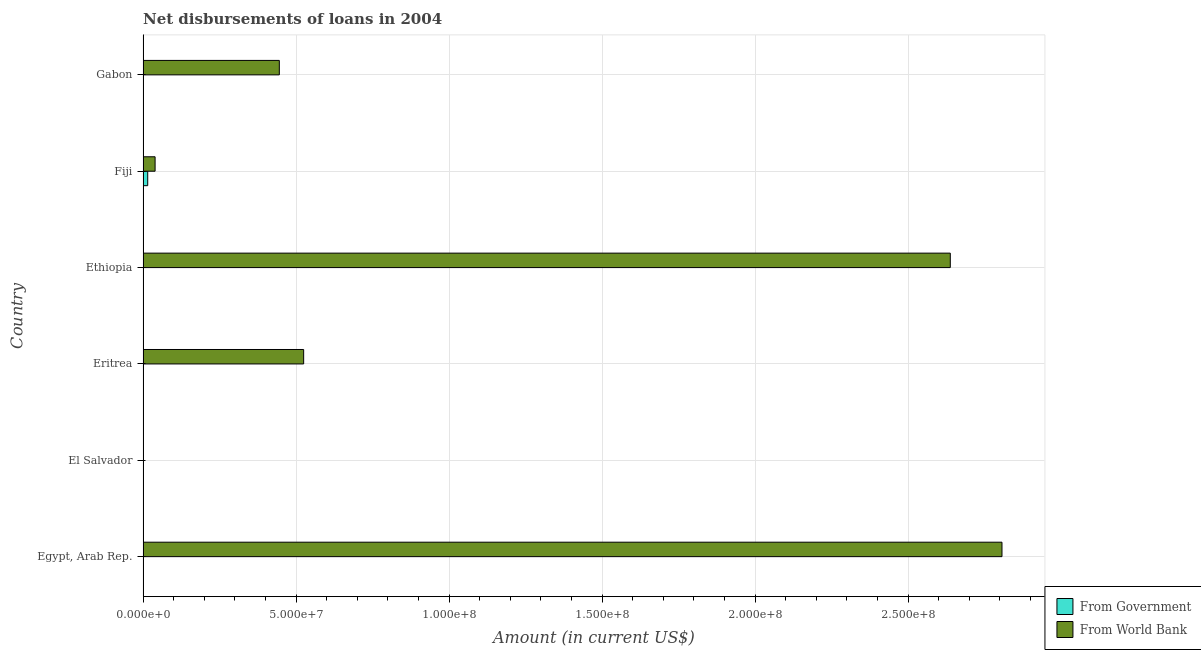Are the number of bars on each tick of the Y-axis equal?
Offer a very short reply. No. How many bars are there on the 3rd tick from the top?
Provide a succinct answer. 1. How many bars are there on the 1st tick from the bottom?
Keep it short and to the point. 1. What is the label of the 5th group of bars from the top?
Ensure brevity in your answer.  El Salvador. In how many cases, is the number of bars for a given country not equal to the number of legend labels?
Offer a terse response. 5. Across all countries, what is the maximum net disbursements of loan from government?
Your answer should be compact. 1.52e+06. Across all countries, what is the minimum net disbursements of loan from government?
Give a very brief answer. 0. In which country was the net disbursements of loan from government maximum?
Your answer should be very brief. Fiji. What is the total net disbursements of loan from government in the graph?
Make the answer very short. 1.52e+06. What is the difference between the net disbursements of loan from world bank in Ethiopia and that in Gabon?
Your answer should be compact. 2.19e+08. What is the difference between the net disbursements of loan from government in Fiji and the net disbursements of loan from world bank in Egypt, Arab Rep.?
Provide a succinct answer. -2.79e+08. What is the average net disbursements of loan from government per country?
Offer a very short reply. 2.54e+05. What is the difference between the net disbursements of loan from government and net disbursements of loan from world bank in Fiji?
Ensure brevity in your answer.  -2.41e+06. In how many countries, is the net disbursements of loan from world bank greater than 230000000 US$?
Your answer should be very brief. 2. What is the ratio of the net disbursements of loan from world bank in Eritrea to that in Ethiopia?
Your response must be concise. 0.2. What is the difference between the highest and the second highest net disbursements of loan from world bank?
Keep it short and to the point. 1.69e+07. What is the difference between the highest and the lowest net disbursements of loan from government?
Make the answer very short. 1.52e+06. In how many countries, is the net disbursements of loan from world bank greater than the average net disbursements of loan from world bank taken over all countries?
Your answer should be very brief. 2. Is the sum of the net disbursements of loan from world bank in Eritrea and Fiji greater than the maximum net disbursements of loan from government across all countries?
Provide a short and direct response. Yes. How many bars are there?
Offer a terse response. 6. How many countries are there in the graph?
Ensure brevity in your answer.  6. What is the difference between two consecutive major ticks on the X-axis?
Your response must be concise. 5.00e+07. Are the values on the major ticks of X-axis written in scientific E-notation?
Provide a succinct answer. Yes. Does the graph contain any zero values?
Offer a very short reply. Yes. How many legend labels are there?
Your answer should be very brief. 2. How are the legend labels stacked?
Ensure brevity in your answer.  Vertical. What is the title of the graph?
Keep it short and to the point. Net disbursements of loans in 2004. What is the label or title of the X-axis?
Offer a terse response. Amount (in current US$). What is the Amount (in current US$) in From World Bank in Egypt, Arab Rep.?
Your answer should be very brief. 2.81e+08. What is the Amount (in current US$) in From Government in El Salvador?
Your answer should be very brief. 0. What is the Amount (in current US$) of From World Bank in El Salvador?
Your answer should be very brief. 0. What is the Amount (in current US$) of From Government in Eritrea?
Provide a short and direct response. 0. What is the Amount (in current US$) of From World Bank in Eritrea?
Ensure brevity in your answer.  5.25e+07. What is the Amount (in current US$) of From World Bank in Ethiopia?
Ensure brevity in your answer.  2.64e+08. What is the Amount (in current US$) in From Government in Fiji?
Provide a short and direct response. 1.52e+06. What is the Amount (in current US$) in From World Bank in Fiji?
Provide a short and direct response. 3.93e+06. What is the Amount (in current US$) in From World Bank in Gabon?
Provide a short and direct response. 4.45e+07. Across all countries, what is the maximum Amount (in current US$) in From Government?
Make the answer very short. 1.52e+06. Across all countries, what is the maximum Amount (in current US$) in From World Bank?
Your response must be concise. 2.81e+08. Across all countries, what is the minimum Amount (in current US$) in From Government?
Give a very brief answer. 0. Across all countries, what is the minimum Amount (in current US$) of From World Bank?
Make the answer very short. 0. What is the total Amount (in current US$) of From Government in the graph?
Give a very brief answer. 1.52e+06. What is the total Amount (in current US$) in From World Bank in the graph?
Ensure brevity in your answer.  6.45e+08. What is the difference between the Amount (in current US$) in From World Bank in Egypt, Arab Rep. and that in Eritrea?
Make the answer very short. 2.28e+08. What is the difference between the Amount (in current US$) in From World Bank in Egypt, Arab Rep. and that in Ethiopia?
Your answer should be very brief. 1.69e+07. What is the difference between the Amount (in current US$) in From World Bank in Egypt, Arab Rep. and that in Fiji?
Your answer should be compact. 2.77e+08. What is the difference between the Amount (in current US$) of From World Bank in Egypt, Arab Rep. and that in Gabon?
Offer a terse response. 2.36e+08. What is the difference between the Amount (in current US$) in From World Bank in Eritrea and that in Ethiopia?
Make the answer very short. -2.11e+08. What is the difference between the Amount (in current US$) of From World Bank in Eritrea and that in Fiji?
Provide a succinct answer. 4.86e+07. What is the difference between the Amount (in current US$) of From World Bank in Eritrea and that in Gabon?
Your answer should be very brief. 7.95e+06. What is the difference between the Amount (in current US$) of From World Bank in Ethiopia and that in Fiji?
Give a very brief answer. 2.60e+08. What is the difference between the Amount (in current US$) in From World Bank in Ethiopia and that in Gabon?
Ensure brevity in your answer.  2.19e+08. What is the difference between the Amount (in current US$) of From World Bank in Fiji and that in Gabon?
Keep it short and to the point. -4.06e+07. What is the difference between the Amount (in current US$) in From Government in Fiji and the Amount (in current US$) in From World Bank in Gabon?
Provide a short and direct response. -4.30e+07. What is the average Amount (in current US$) of From Government per country?
Ensure brevity in your answer.  2.54e+05. What is the average Amount (in current US$) in From World Bank per country?
Your answer should be very brief. 1.08e+08. What is the difference between the Amount (in current US$) in From Government and Amount (in current US$) in From World Bank in Fiji?
Your answer should be very brief. -2.41e+06. What is the ratio of the Amount (in current US$) in From World Bank in Egypt, Arab Rep. to that in Eritrea?
Provide a succinct answer. 5.35. What is the ratio of the Amount (in current US$) of From World Bank in Egypt, Arab Rep. to that in Ethiopia?
Offer a very short reply. 1.06. What is the ratio of the Amount (in current US$) of From World Bank in Egypt, Arab Rep. to that in Fiji?
Your answer should be compact. 71.36. What is the ratio of the Amount (in current US$) of From World Bank in Egypt, Arab Rep. to that in Gabon?
Your response must be concise. 6.3. What is the ratio of the Amount (in current US$) in From World Bank in Eritrea to that in Ethiopia?
Provide a short and direct response. 0.2. What is the ratio of the Amount (in current US$) in From World Bank in Eritrea to that in Fiji?
Make the answer very short. 13.34. What is the ratio of the Amount (in current US$) of From World Bank in Eritrea to that in Gabon?
Offer a terse response. 1.18. What is the ratio of the Amount (in current US$) of From World Bank in Ethiopia to that in Fiji?
Offer a terse response. 67.06. What is the ratio of the Amount (in current US$) of From World Bank in Ethiopia to that in Gabon?
Your answer should be compact. 5.92. What is the ratio of the Amount (in current US$) in From World Bank in Fiji to that in Gabon?
Keep it short and to the point. 0.09. What is the difference between the highest and the second highest Amount (in current US$) of From World Bank?
Your answer should be very brief. 1.69e+07. What is the difference between the highest and the lowest Amount (in current US$) in From Government?
Ensure brevity in your answer.  1.52e+06. What is the difference between the highest and the lowest Amount (in current US$) of From World Bank?
Your answer should be compact. 2.81e+08. 